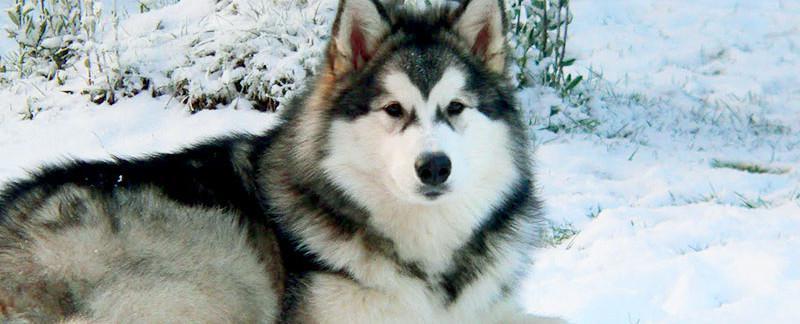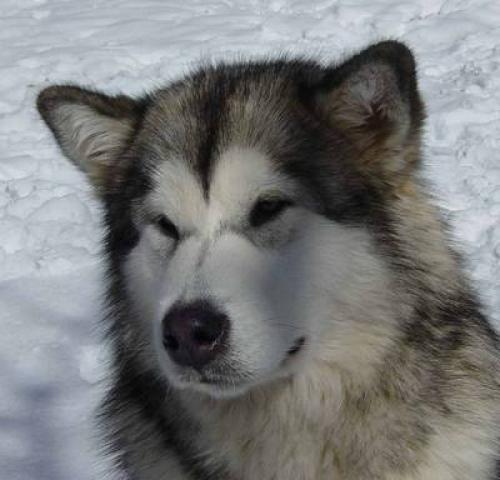The first image is the image on the left, the second image is the image on the right. For the images displayed, is the sentence "There are exactly two dogs posing in a snowy environment." factually correct? Answer yes or no. Yes. The first image is the image on the left, the second image is the image on the right. For the images shown, is this caption "The left image features one non-reclining dog with snow on its face, and the right image includes at least one forward-facing dog with its tongue hanging down." true? Answer yes or no. No. 